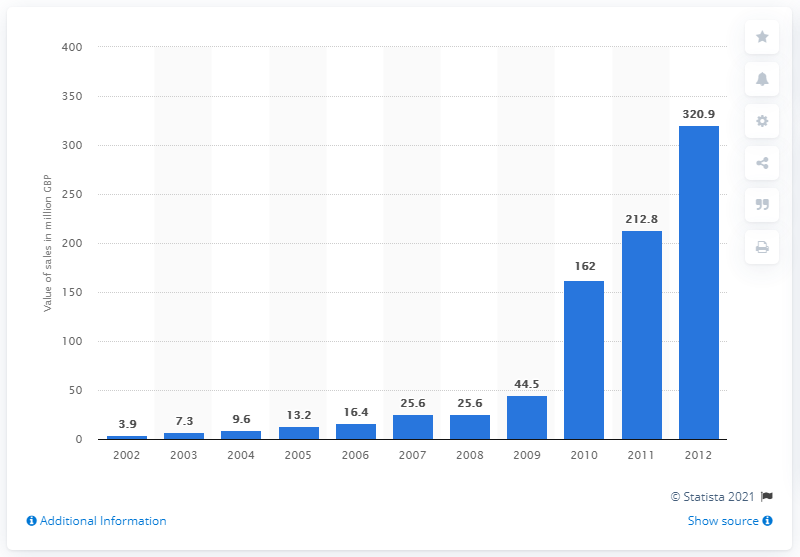List a handful of essential elements in this visual. In 2012, the peak sales value of fairtrade cocoa products in the UK was £320.9 million. 